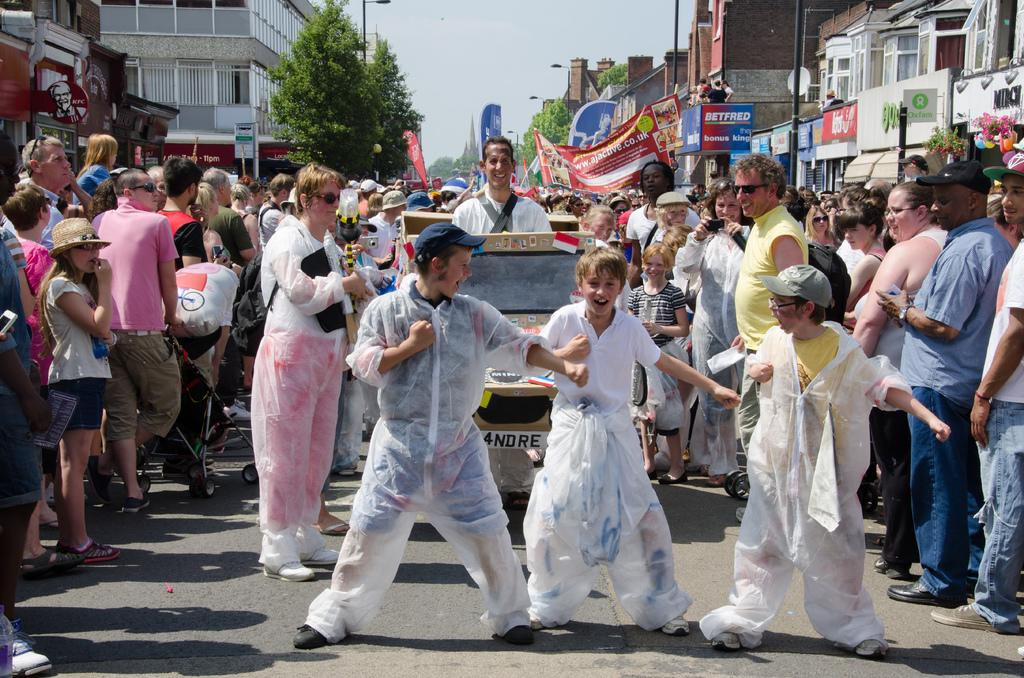How many people are in the image? There are people in the image, but the exact number is not specified. What type of vehicle is in the image? There is a vehicle in the image, but the specific type is not mentioned. What is the stroller used for in the image? The stroller is likely used for transporting a child or carrying items, but the image does not provide specific details. What do the banners in the image represent? The banners in the image may represent an event or a message, but their exact meaning is not clear. What are the boards in the image used for? The boards in the image may be used for displaying information or as a surface for writing or drawing, but their specific purpose is not mentioned. What are the poles in the image used for? The poles in the image may be used for supporting banners, signs, or other objects, but their specific purpose is not mentioned. What type of trees are in the image? The type of trees in the image is not specified. What type of buildings are in the image? The type of buildings in the image is not specified. What is visible in the background of the image? The sky is visible in the background of the image. How many hammers are visible in the image? There are no hammers visible in the image. What type of mist can be seen in the image? There is no mist present in the image. How many boys are visible in the image? The number of boys in the image is not specified. 